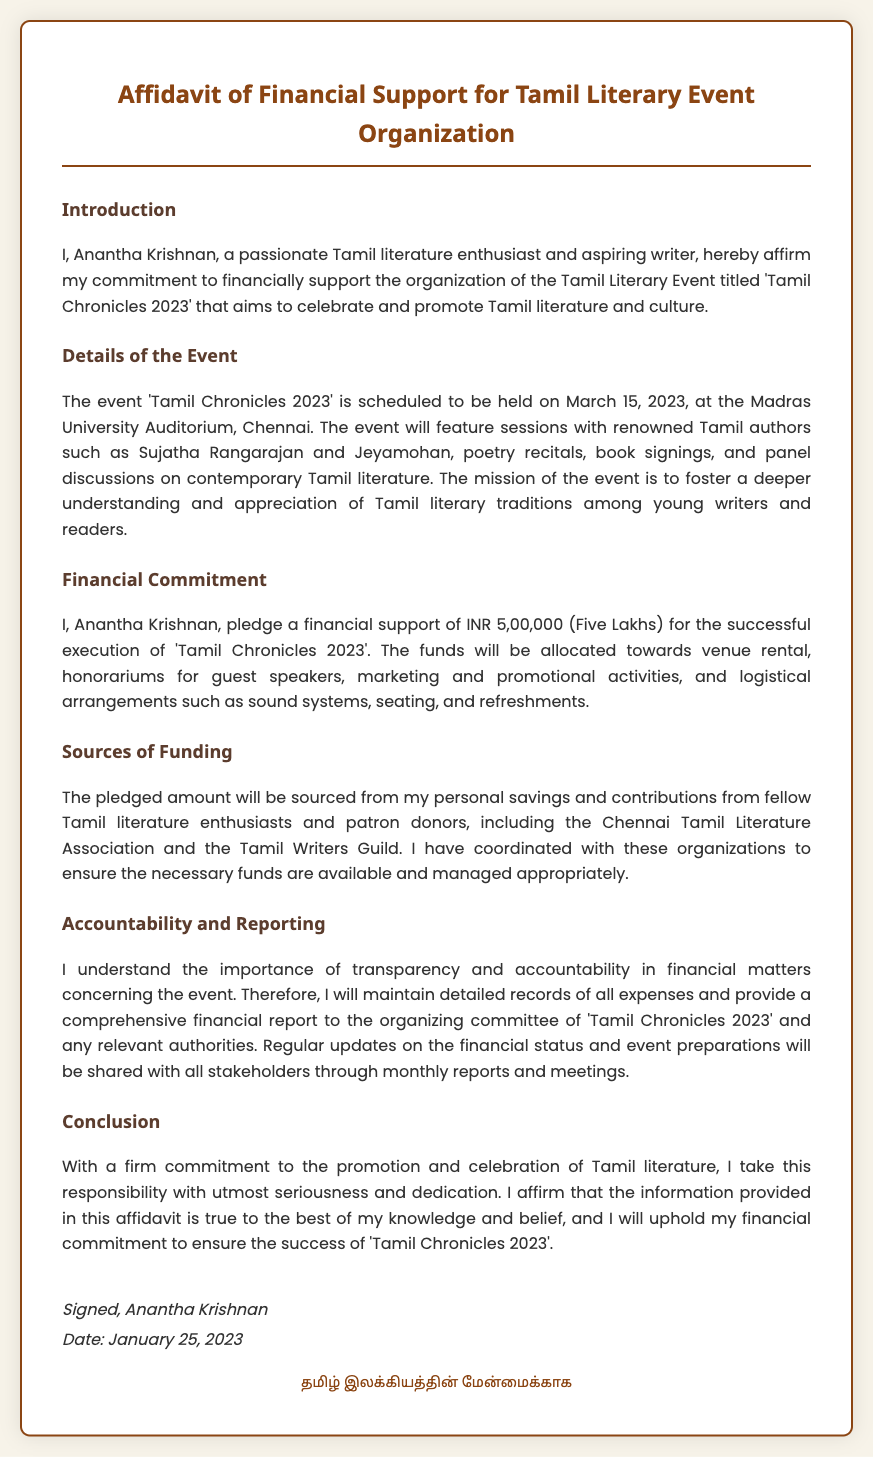what is the name of the event? The name of the event is mentioned in the document as 'Tamil Chronicles 2023'.
Answer: 'Tamil Chronicles 2023' who is the financial supporter? The affidavit clearly states the financial supporter as Anantha Krishnan.
Answer: Anantha Krishnan when is the event scheduled? The date of the event is specified in the document as March 15, 2023.
Answer: March 15, 2023 how much financial support is pledged? The document indicates that the financial support pledged is INR 5,00,000 (Five Lakhs).
Answer: INR 5,00,000 which venue will host the event? The venue mentioned for the event is the Madras University Auditorium, Chennai.
Answer: Madras University Auditorium, Chennai what are the planned activities for the event? The document lists several activities, including sessions with renowned Tamil authors, poetry recitals, and book signings.
Answer: sessions with renowned Tamil authors, poetry recitals, and book signings how will the funds be managed? The affidavit states that detailed records of all expenses will be maintained for accountability.
Answer: detailed records of all expenses what organizations are contributing to the funding? It mentions contributions from the Chennai Tamil Literature Association and the Tamil Writers Guild.
Answer: Chennai Tamil Literature Association and the Tamil Writers Guild what is the purpose of the affidavit? The purpose is to affirm the financial commitment for organizing the Tamil Literary Event.
Answer: affirm the financial commitment for organizing the Tamil Literary Event significance of transparency as mentioned in the document? Transparency is important for maintaining accountability in financial matters concerning the event.
Answer: maintaining accountability in financial matters 